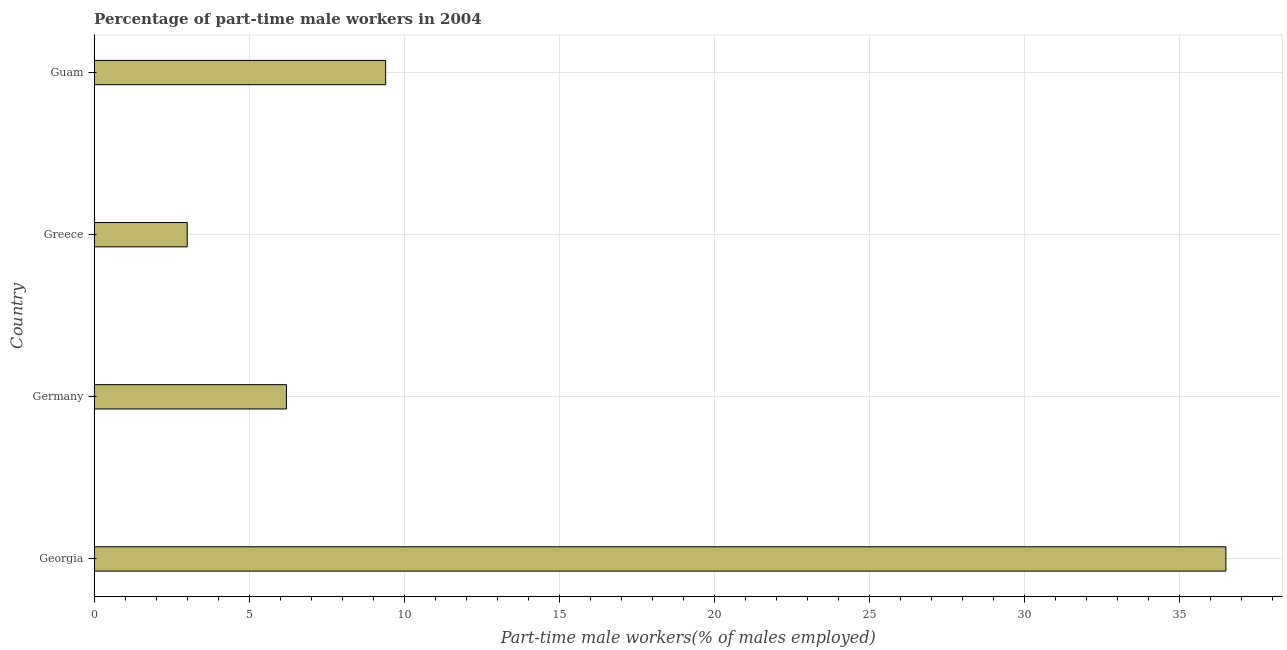Does the graph contain any zero values?
Provide a short and direct response. No. Does the graph contain grids?
Your answer should be compact. Yes. What is the title of the graph?
Your answer should be very brief. Percentage of part-time male workers in 2004. What is the label or title of the X-axis?
Your answer should be very brief. Part-time male workers(% of males employed). What is the label or title of the Y-axis?
Your answer should be very brief. Country. Across all countries, what is the maximum percentage of part-time male workers?
Your response must be concise. 36.5. In which country was the percentage of part-time male workers maximum?
Give a very brief answer. Georgia. In which country was the percentage of part-time male workers minimum?
Provide a short and direct response. Greece. What is the sum of the percentage of part-time male workers?
Your response must be concise. 55.1. What is the difference between the percentage of part-time male workers in Greece and Guam?
Provide a short and direct response. -6.4. What is the average percentage of part-time male workers per country?
Ensure brevity in your answer.  13.78. What is the median percentage of part-time male workers?
Make the answer very short. 7.8. In how many countries, is the percentage of part-time male workers greater than 7 %?
Your response must be concise. 2. What is the ratio of the percentage of part-time male workers in Georgia to that in Guam?
Your answer should be very brief. 3.88. Is the percentage of part-time male workers in Germany less than that in Guam?
Your answer should be compact. Yes. Is the difference between the percentage of part-time male workers in Georgia and Greece greater than the difference between any two countries?
Keep it short and to the point. Yes. What is the difference between the highest and the second highest percentage of part-time male workers?
Give a very brief answer. 27.1. What is the difference between the highest and the lowest percentage of part-time male workers?
Your response must be concise. 33.5. How many bars are there?
Offer a very short reply. 4. Are all the bars in the graph horizontal?
Provide a succinct answer. Yes. How many countries are there in the graph?
Your answer should be very brief. 4. What is the difference between two consecutive major ticks on the X-axis?
Offer a terse response. 5. Are the values on the major ticks of X-axis written in scientific E-notation?
Give a very brief answer. No. What is the Part-time male workers(% of males employed) in Georgia?
Your answer should be compact. 36.5. What is the Part-time male workers(% of males employed) of Germany?
Your response must be concise. 6.2. What is the Part-time male workers(% of males employed) of Guam?
Make the answer very short. 9.4. What is the difference between the Part-time male workers(% of males employed) in Georgia and Germany?
Offer a very short reply. 30.3. What is the difference between the Part-time male workers(% of males employed) in Georgia and Greece?
Offer a very short reply. 33.5. What is the difference between the Part-time male workers(% of males employed) in Georgia and Guam?
Provide a succinct answer. 27.1. What is the ratio of the Part-time male workers(% of males employed) in Georgia to that in Germany?
Your answer should be very brief. 5.89. What is the ratio of the Part-time male workers(% of males employed) in Georgia to that in Greece?
Offer a terse response. 12.17. What is the ratio of the Part-time male workers(% of males employed) in Georgia to that in Guam?
Ensure brevity in your answer.  3.88. What is the ratio of the Part-time male workers(% of males employed) in Germany to that in Greece?
Offer a terse response. 2.07. What is the ratio of the Part-time male workers(% of males employed) in Germany to that in Guam?
Offer a terse response. 0.66. What is the ratio of the Part-time male workers(% of males employed) in Greece to that in Guam?
Your response must be concise. 0.32. 